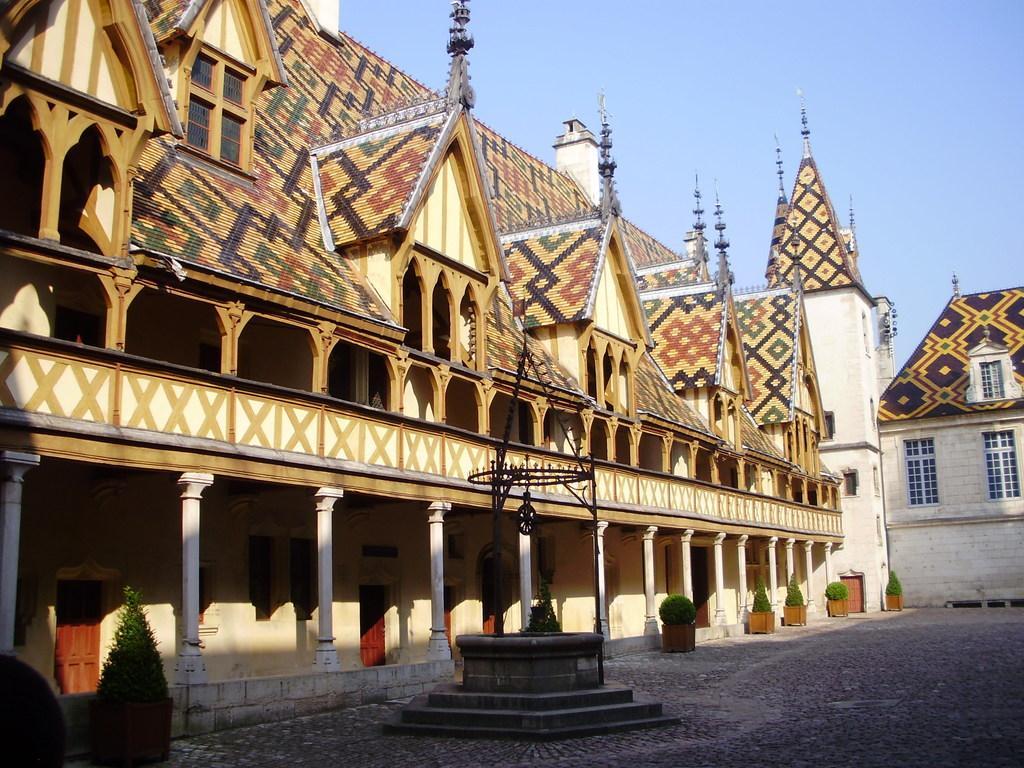In one or two sentences, can you explain what this image depicts? In this image I can see the ground, few stairs, few plants which are green in color and few buildings. In the background I can see the sky. 